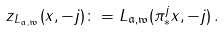<formula> <loc_0><loc_0><loc_500><loc_500>z _ { L _ { { \mathfrak a } , \mathfrak w } } ( x , - j ) \colon = L _ { { \mathfrak a } , \mathfrak w } ( \pi _ { \ast } ^ { j } x , - j ) \, .</formula> 